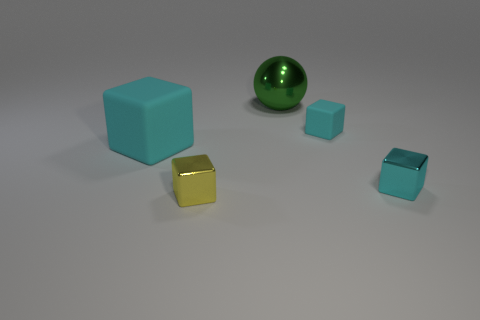What is the size of the other matte block that is the same color as the tiny rubber cube?
Provide a short and direct response. Large. Is the tiny yellow object made of the same material as the cyan cube left of the small rubber cube?
Your answer should be compact. No. The matte cube that is behind the large object on the left side of the shiny cube that is in front of the small cyan metal block is what color?
Provide a succinct answer. Cyan. What is the shape of the yellow shiny object that is the same size as the cyan shiny cube?
Offer a very short reply. Cube. Does the cyan rubber thing on the left side of the small matte object have the same size as the block that is on the right side of the tiny cyan rubber thing?
Provide a succinct answer. No. What is the size of the metallic block on the right side of the ball?
Your answer should be very brief. Small. What is the material of the small object that is the same color as the small rubber block?
Keep it short and to the point. Metal. What color is the block that is the same size as the green shiny thing?
Provide a succinct answer. Cyan. Do the cyan metal cube and the green ball have the same size?
Keep it short and to the point. No. There is a thing that is both behind the big cyan cube and in front of the big ball; what is its size?
Offer a very short reply. Small. 